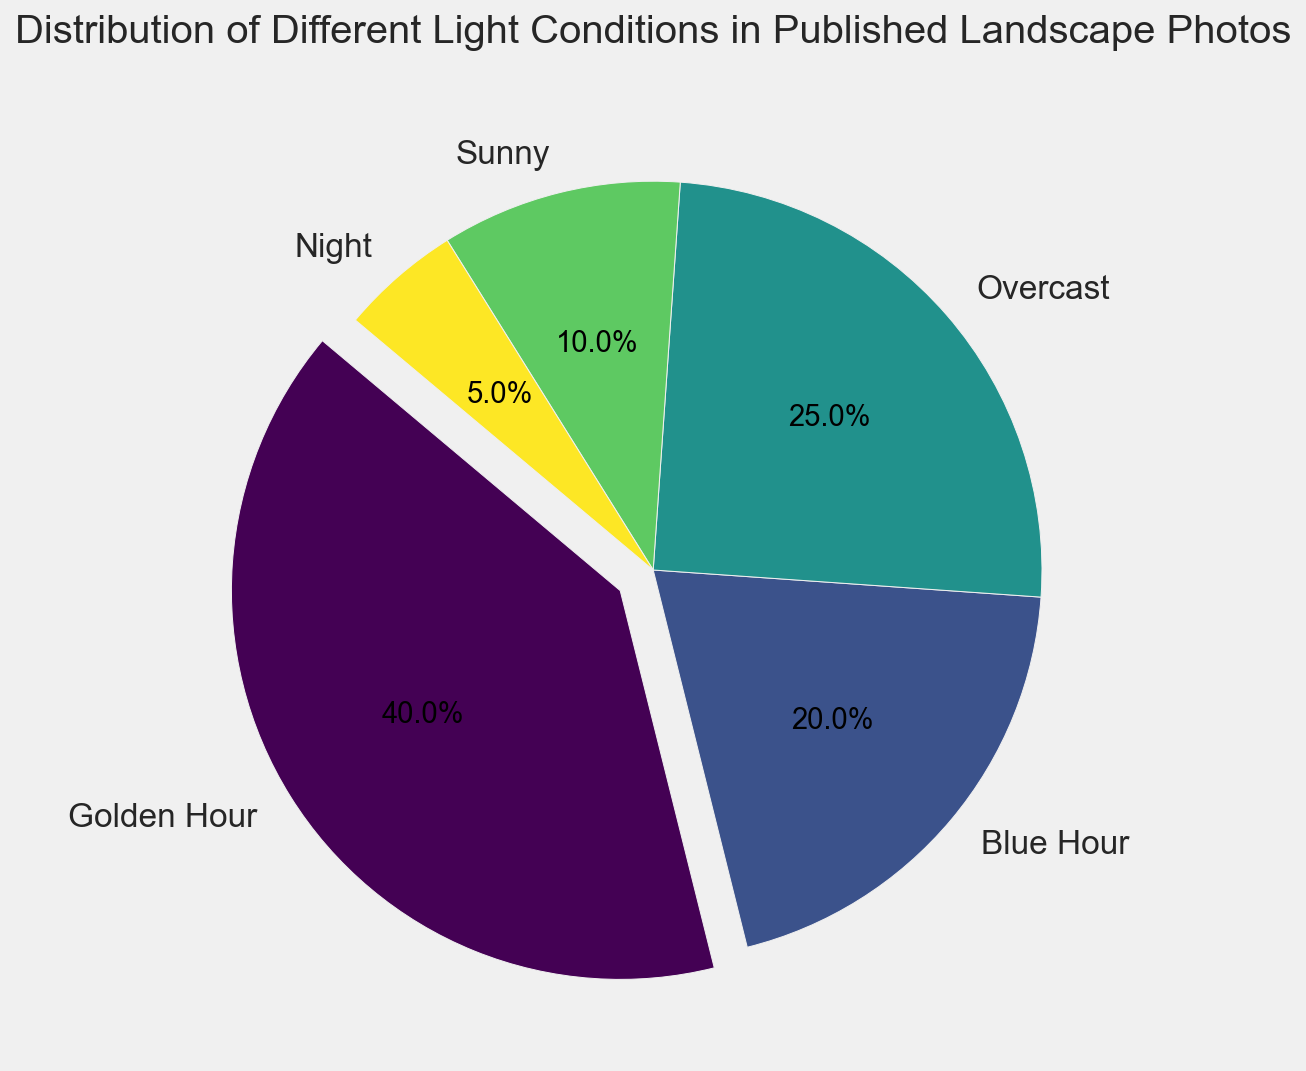Which light condition is most commonly depicted in the published landscape photos? The pie chart shows the distribution percentages of different light conditions. The largest portion of the pie chart corresponds to "Golden Hour," which has a percentage of 40%, indicating it is the most common.
Answer: Golden Hour Which light condition is least frequently depicted in the photos? The smallest section of the pie chart represents the "Night" category, which has a percentage of 5%, making it the least frequent.
Answer: Night What is the combined percentage of photos taken during Golden Hour and Blue Hour? The pie chart shows "Golden Hour" at 40% and "Blue Hour" at 20%. Adding these together, 40% + 20% = 60%.
Answer: 60% Is the percentage of photos taken on overcast days greater or less than those taken during sunny conditions? The chart shows "Overcast" at 25% and "Sunny" at 10%. 25% is greater than 10%.
Answer: Greater Which two light conditions together constitute exactly half of the published photos? By examining the percentages, "Golden Hour" (40%) and "Blue Hour" (20%) add up to 40% + 20% = 60%, which is more than half. However, "Overcast" (25%) and "Sunny" (10%) add up to 25% + 10% = 35%, which is less than 50%. By revisiting the possible combinations, we find no two conditions together make exactly half. Therefore, no combination exists.
Answer: None How does the percentage of photos taken at night compare to those taken at golden hour? The "Golden Hour" segment shows 40%, while the "Night" segment is at 5%. 40% is much greater than 5%.
Answer: Golden Hour is greater What is the visual difference in the pie chart between the most and least frequent light conditions? The most frequent "Golden Hour" has a highlighted (exploded) segment and the largest area, while the least frequent "Night" has the smallest segment without explosion. Color shades are also distinct, with "Golden Hour" potentially having a more prominent color.
Answer: Highlighted, larger segment, distinct color What's the combined percentage of photos taken in conditions other than Golden Hour? The pie chart has Golden Hour at 40%. The total percentage must be 100%, so, subtracting this, we calculate 100% - 40% = 60%.
Answer: 60% Are there more photos taken during Overcast or Blue Hour conditions? The pie chart shows "Overcast" at 25% and "Blue Hour" at 20%. Hence, 25% > 20%.
Answer: Overcast Is the distribution of published photos evenly spread across the different light conditions? We examine the percentages: Golden Hour (40%), Blue Hour (20%), Overcast (25%), Sunny (10%), Night (5%). These values are not close to each other, indicating an uneven distribution.
Answer: No 